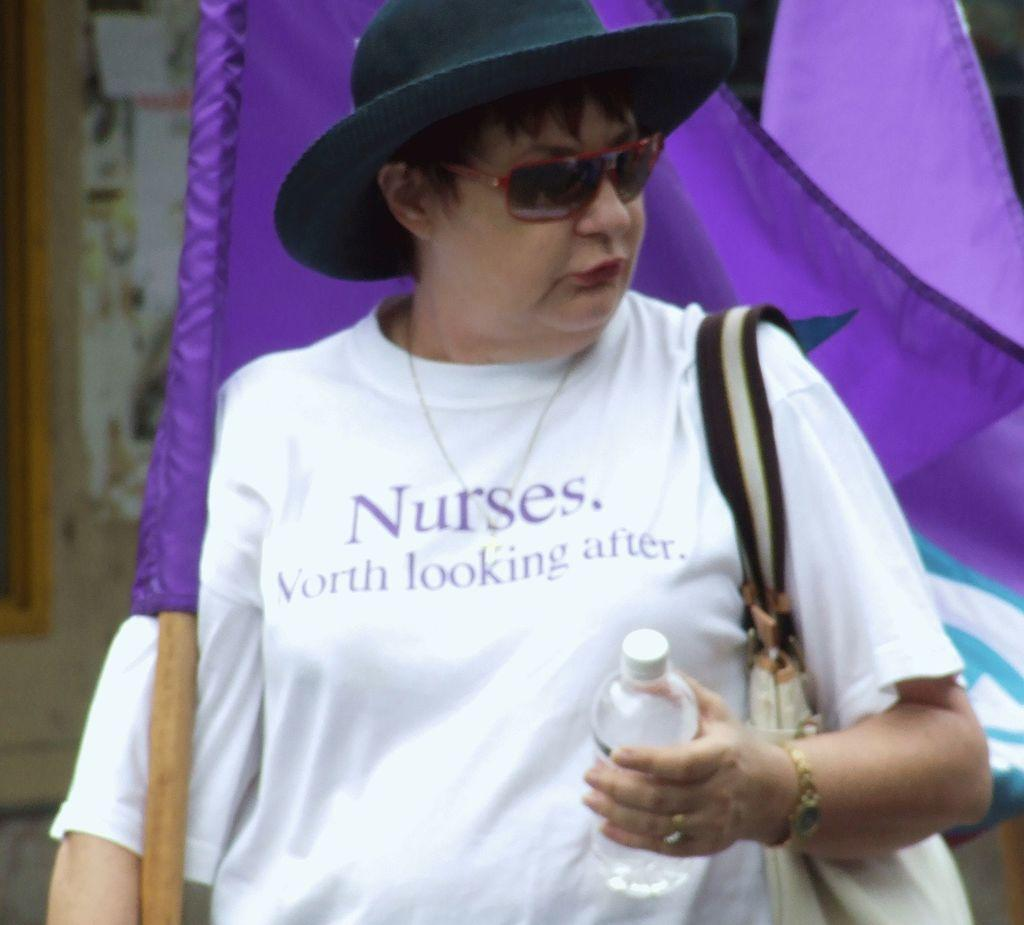Who is the main subject in the image? There is a woman in the image. What is the woman holding in her hand? The woman is holding a water bottle and a flag in her hand. What accessories is the woman wearing? The woman is wearing spectacles and a hat. What is the woman doing in the image? The woman is walking. What type of pen can be seen in the woman's hand in the image? There is no pen visible in the woman's hand in the image; she is holding a water bottle and a flag. Can you tell me how many wrens are perched on the woman's hat in the image? There are no wrens present in the image; the woman is wearing a hat, but no birds are visible. 